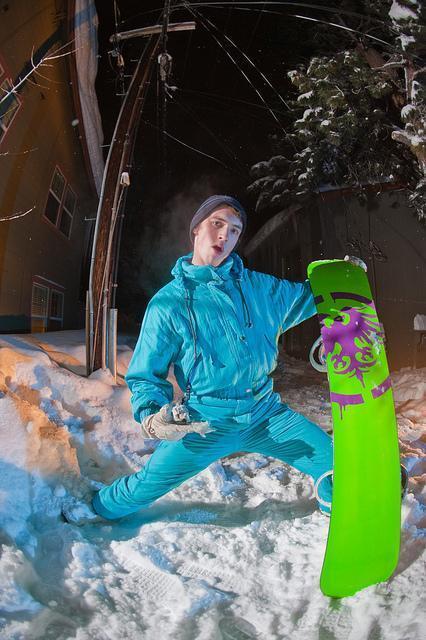How many people are there?
Give a very brief answer. 1. How many trees to the left of the giraffe are there?
Give a very brief answer. 0. 